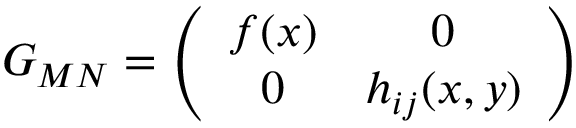<formula> <loc_0><loc_0><loc_500><loc_500>G _ { M N } = \left ( \begin{array} { c c } { f ( x ) } & { 0 } \\ { 0 } & { { h _ { i j } ( x , y ) } } \end{array} \right )</formula> 